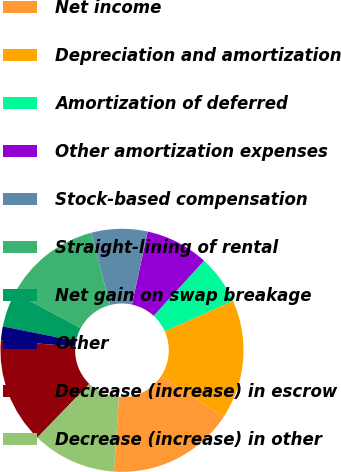Convert chart. <chart><loc_0><loc_0><loc_500><loc_500><pie_chart><fcel>Net income<fcel>Depreciation and amortization<fcel>Amortization of deferred<fcel>Other amortization expenses<fcel>Stock-based compensation<fcel>Straight-lining of rental<fcel>Net gain on swap breakage<fcel>Other<fcel>Decrease (increase) in escrow<fcel>Decrease (increase) in other<nl><fcel>16.82%<fcel>15.88%<fcel>6.54%<fcel>8.41%<fcel>7.48%<fcel>13.08%<fcel>4.68%<fcel>1.87%<fcel>14.02%<fcel>11.21%<nl></chart> 